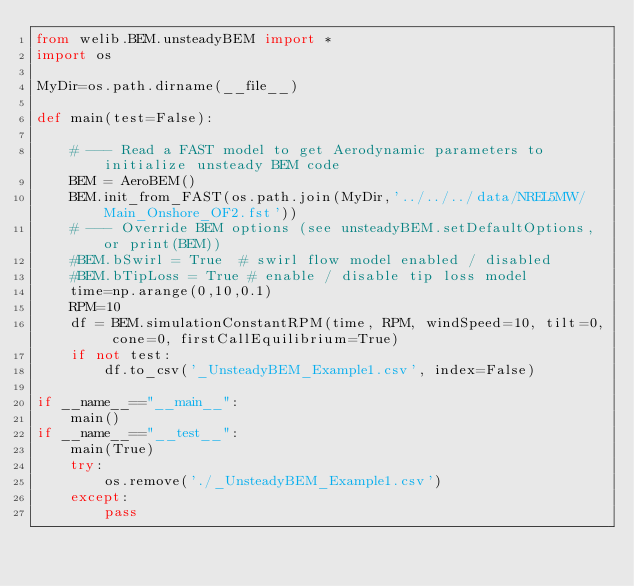Convert code to text. <code><loc_0><loc_0><loc_500><loc_500><_Python_>from welib.BEM.unsteadyBEM import *
import os

MyDir=os.path.dirname(__file__)

def main(test=False):

    # --- Read a FAST model to get Aerodynamic parameters to initialize unsteady BEM code
    BEM = AeroBEM()
    BEM.init_from_FAST(os.path.join(MyDir,'../../../data/NREL5MW/Main_Onshore_OF2.fst'))
    # --- Override BEM options (see unsteadyBEM.setDefaultOptions, or print(BEM))
    #BEM.bSwirl = True  # swirl flow model enabled / disabled
    #BEM.bTipLoss = True # enable / disable tip loss model
    time=np.arange(0,10,0.1)
    RPM=10
    df = BEM.simulationConstantRPM(time, RPM, windSpeed=10, tilt=0, cone=0, firstCallEquilibrium=True)
    if not test:
        df.to_csv('_UnsteadyBEM_Example1.csv', index=False)

if __name__=="__main__":
    main()
if __name__=="__test__":
    main(True)
    try:
        os.remove('./_UnsteadyBEM_Example1.csv')
    except:
        pass

</code> 